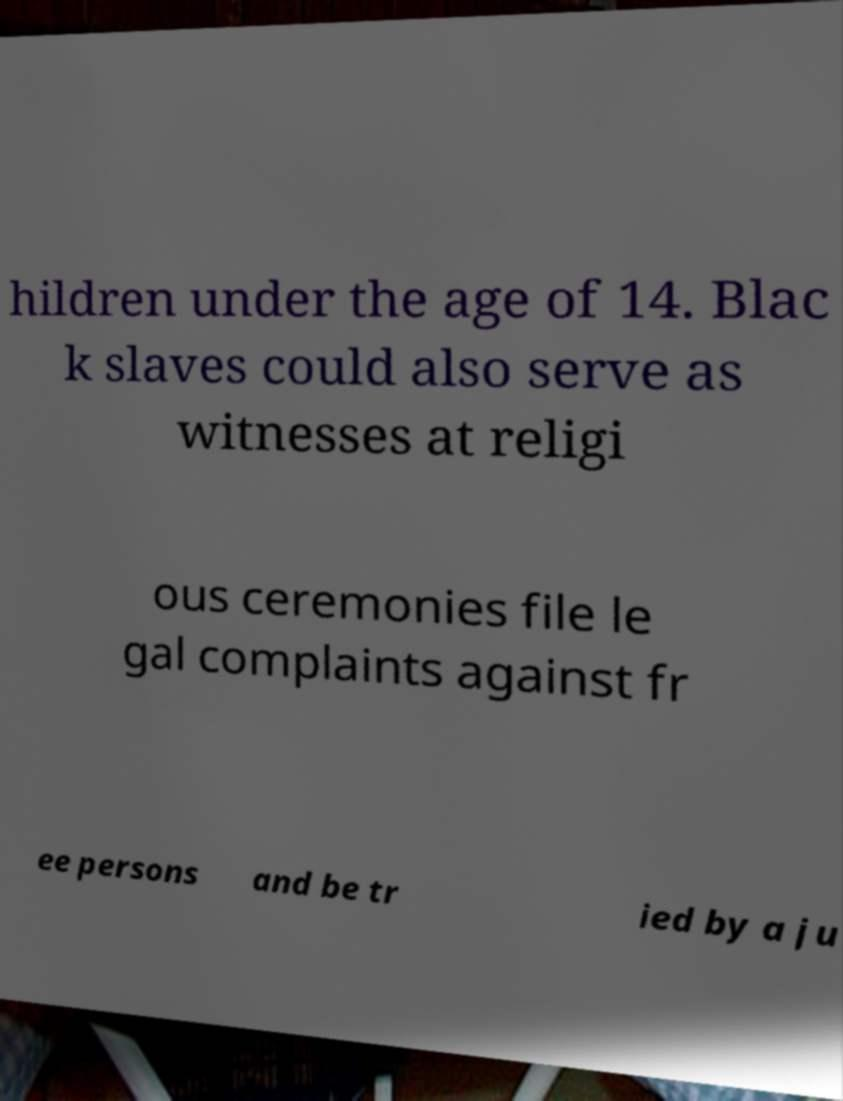Could you assist in decoding the text presented in this image and type it out clearly? hildren under the age of 14. Blac k slaves could also serve as witnesses at religi ous ceremonies file le gal complaints against fr ee persons and be tr ied by a ju 